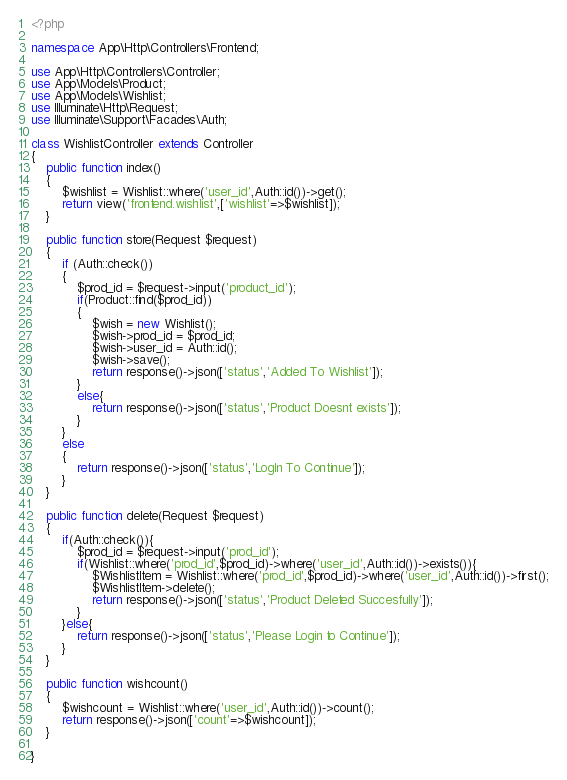Convert code to text. <code><loc_0><loc_0><loc_500><loc_500><_PHP_><?php

namespace App\Http\Controllers\Frontend;

use App\Http\Controllers\Controller;
use App\Models\Product;
use App\Models\Wishlist;
use Illuminate\Http\Request;
use Illuminate\Support\Facades\Auth;

class WishlistController extends Controller
{
    public function index()
    {
        $wishlist = Wishlist::where('user_id',Auth::id())->get();
        return view('frontend.wishlist',['wishlist'=>$wishlist]);
    }

    public function store(Request $request)
    {
        if (Auth::check())
        {
            $prod_id = $request->input('product_id');
            if(Product::find($prod_id))
            {
                $wish = new Wishlist();
                $wish->prod_id = $prod_id;
                $wish->user_id = Auth::id();
                $wish->save();
                return response()->json(['status','Added To Wishlist']);
            }
            else{
                return response()->json(['status','Product Doesnt exists']);
            }
        }
        else
        {
            return response()->json(['status','LogIn To Continue']);
        }
    }

    public function delete(Request $request)
    {
        if(Auth::check()){
            $prod_id = $request->input('prod_id');
            if(Wishlist::where('prod_id',$prod_id)->where('user_id',Auth::id())->exists()){
                $WishlistItem = Wishlist::where('prod_id',$prod_id)->where('user_id',Auth::id())->first();
                $WishlistItem->delete();
                return response()->json(['status','Product Deleted Succesfully']);
            }
        }else{
            return response()->json(['status','Please Login to Continue']);
        }
    }

    public function wishcount()
    {
        $wishcount = Wishlist::where('user_id',Auth::id())->count();
        return response()->json(['count'=>$wishcount]);
    }

}
</code> 